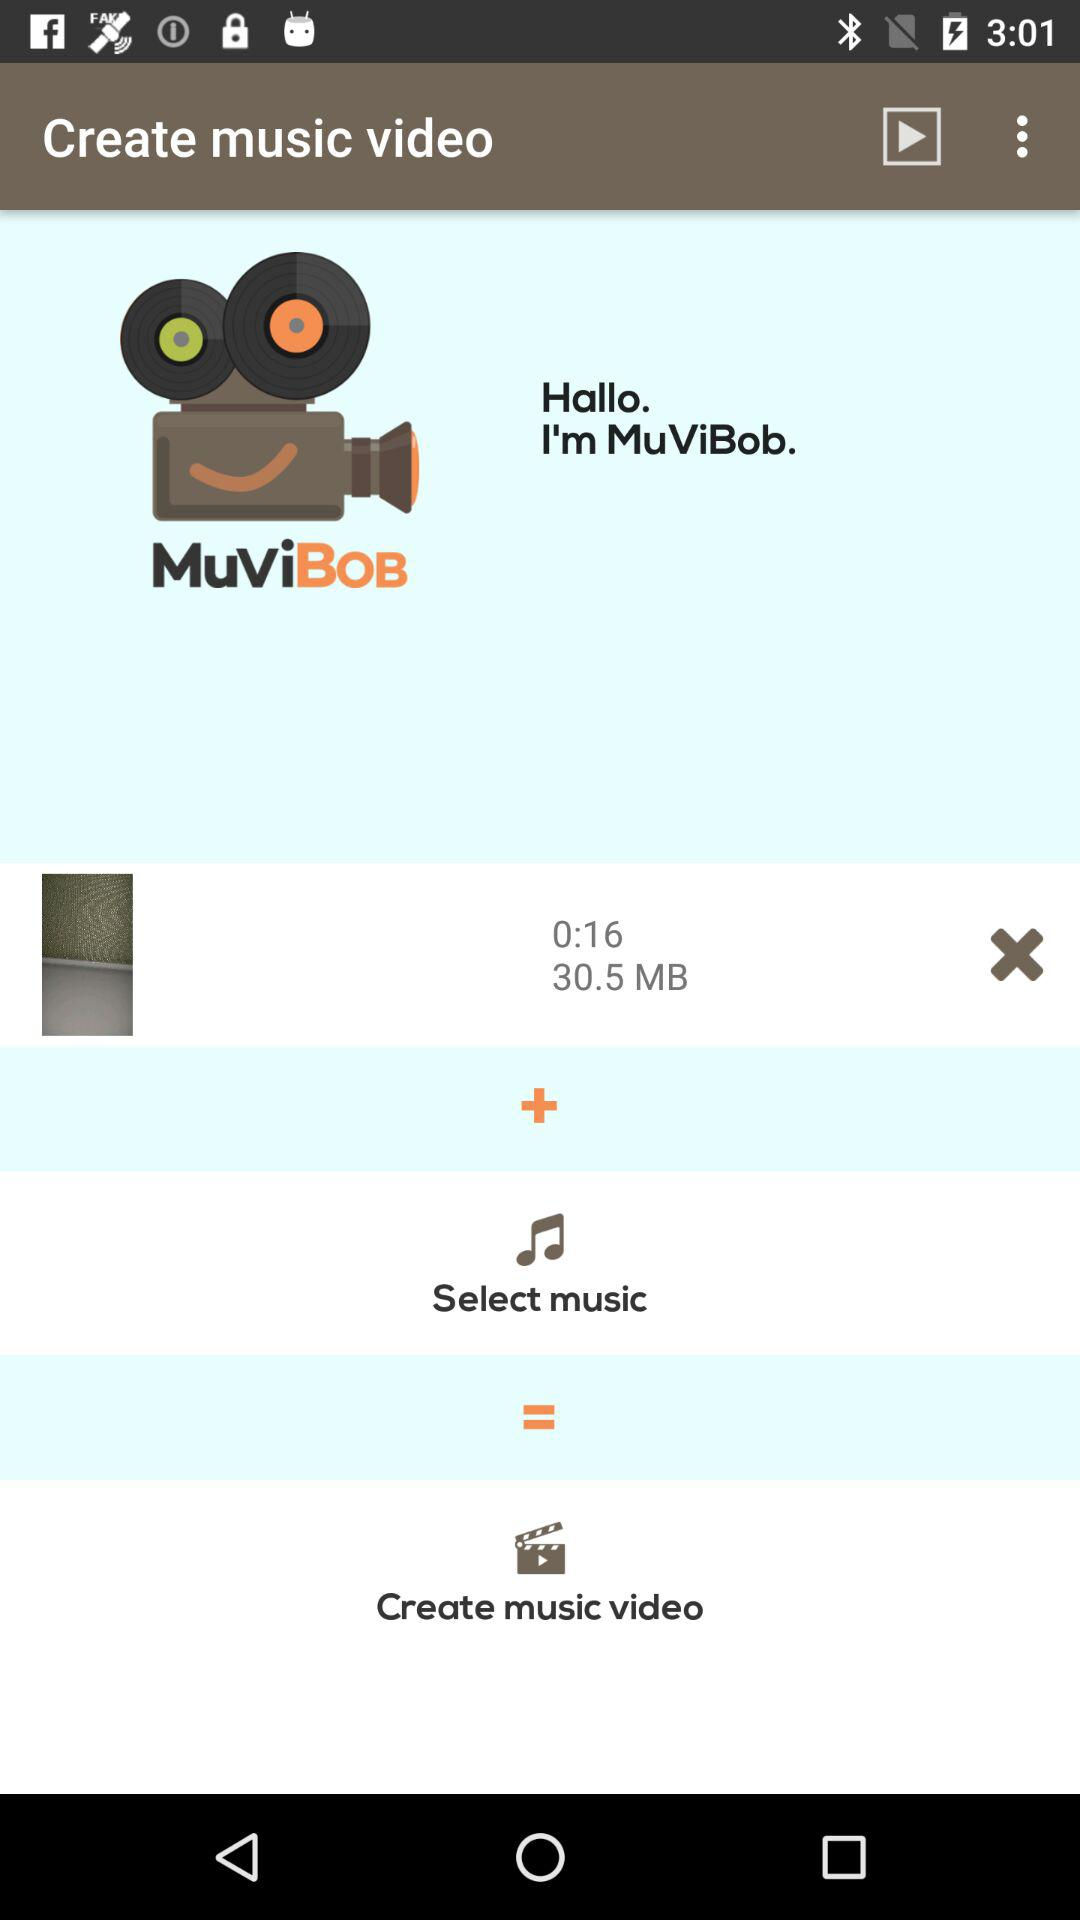What is the file size of the video?
Answer the question using a single word or phrase. 30.5 MB 